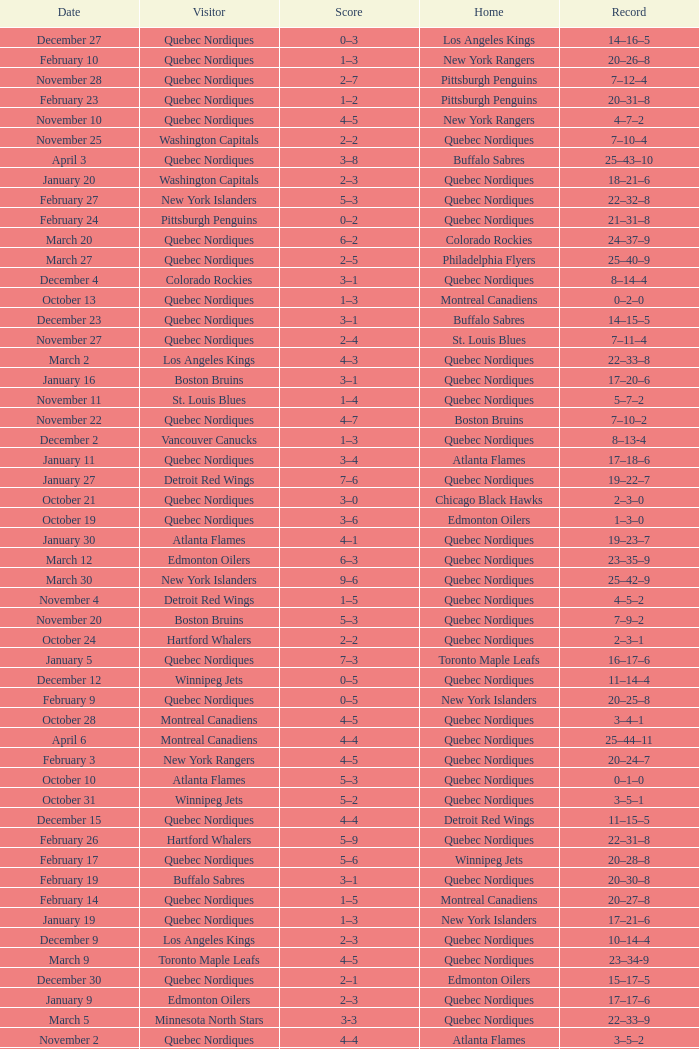Which Home has a Record of 11–14–4? Quebec Nordiques. 